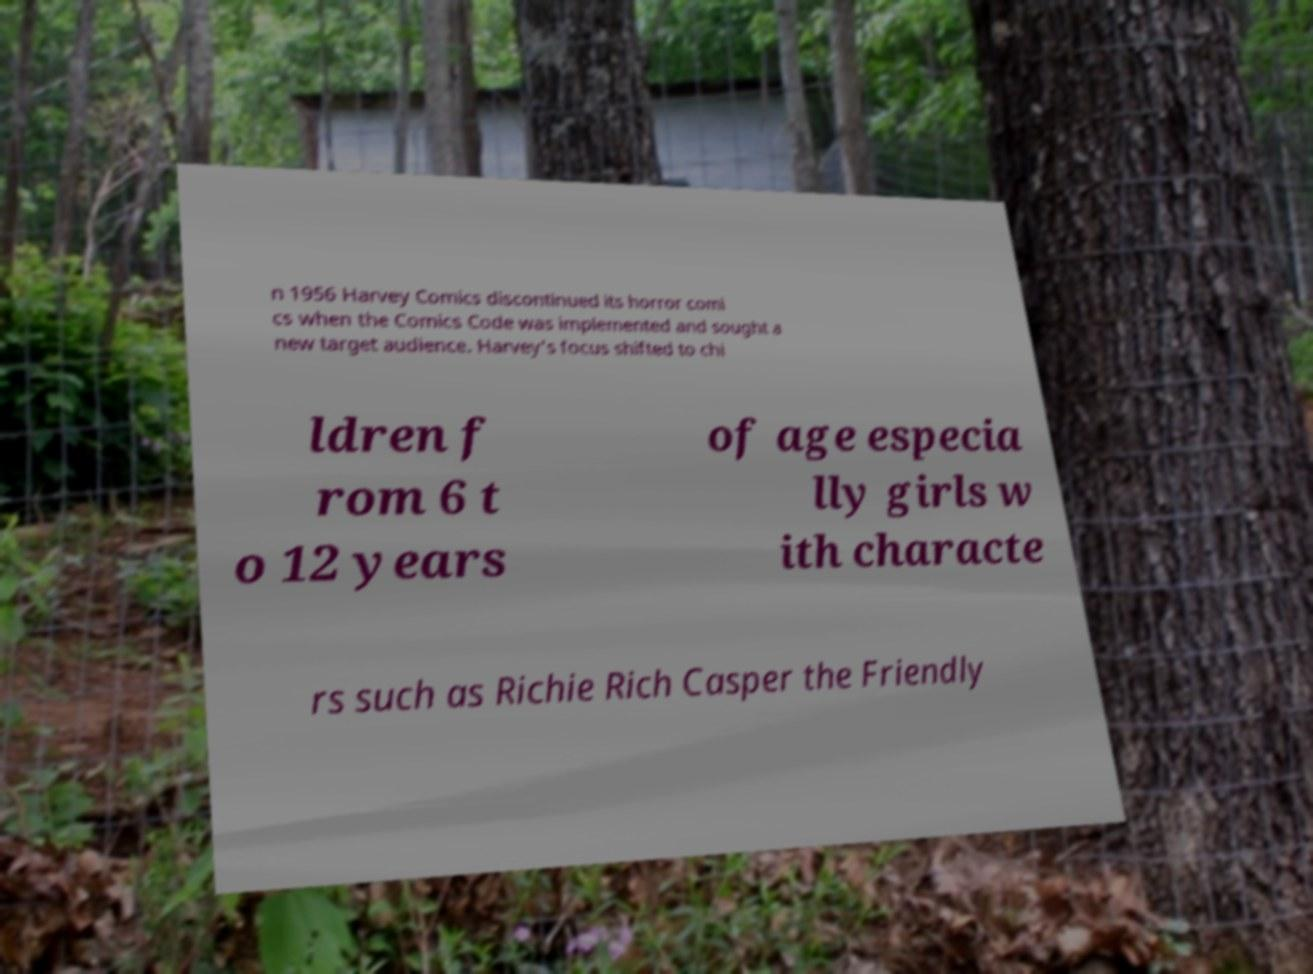For documentation purposes, I need the text within this image transcribed. Could you provide that? n 1956 Harvey Comics discontinued its horror comi cs when the Comics Code was implemented and sought a new target audience. Harvey's focus shifted to chi ldren f rom 6 t o 12 years of age especia lly girls w ith characte rs such as Richie Rich Casper the Friendly 